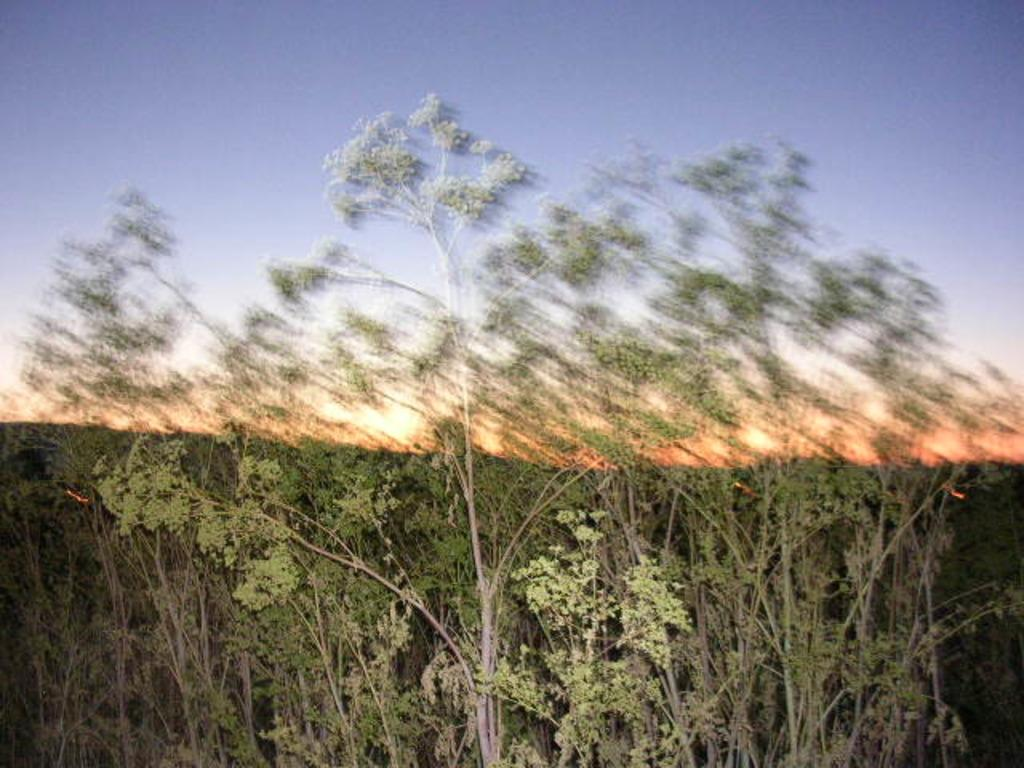What is located in front of the image? There are trees in front of the image. What color is the area behind the trees? The area behind the trees is orange in color. What is visible at the top of the image? The sky is visible at the top of the image. What color is the sky in the image? The sky is blue in color. How would you describe the background of the image? The background of the image is blurred. Can you see a wrench being used in the image? There is no wrench present in the image. What type of system is being depicted in the image? The image does not depict a system; it features trees, an orange area, a blue sky, and a blurred background. 